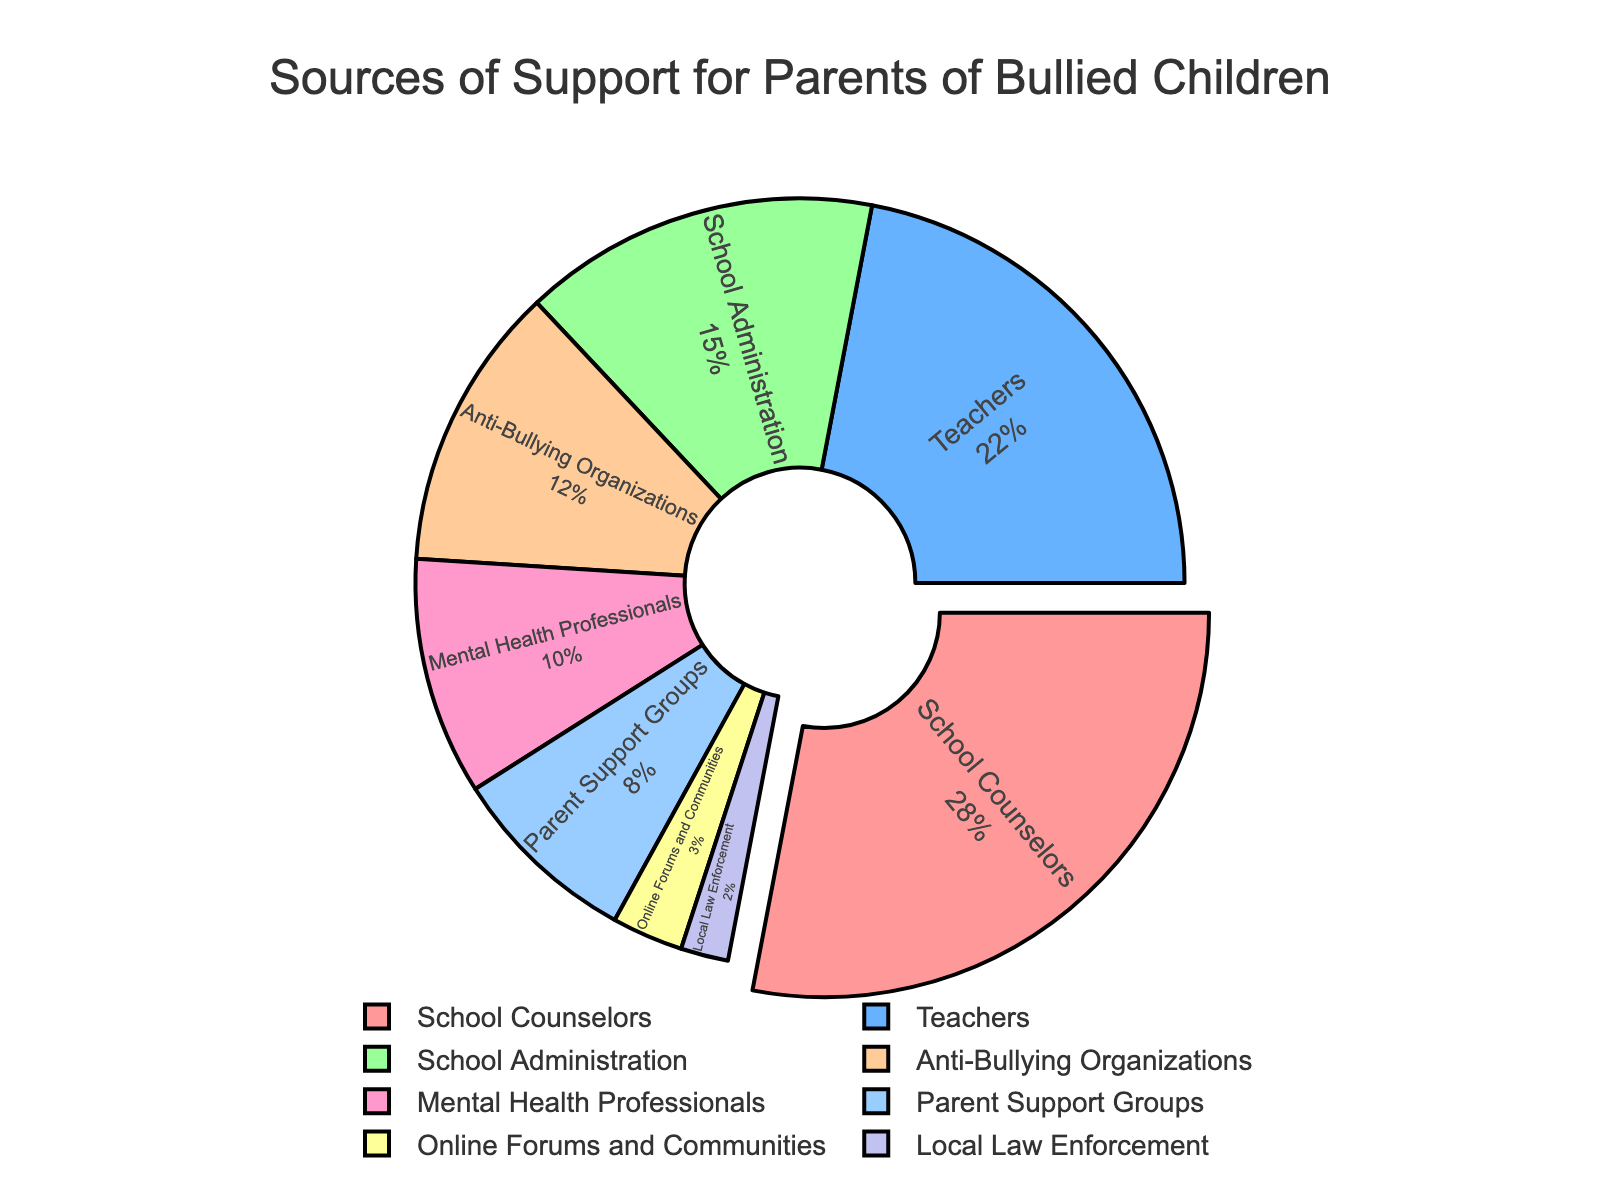What's the most common source of support sought by parents of bullied children? The largest segment in the pie chart indicates the most common source. The "School Counselors" segment is the largest.
Answer: School Counselors Which source of support is least sought by parents? The smallest segment represents the least sought source. The "Local Law Enforcement" segment is the smallest.
Answer: Local Law Enforcement What percentage of support is sought from resources other than "School Counselors"? Sum the percentages of all other segments: 100% - 28%
Answer: 72% How much more frequently do parents seek support from Teachers compared to Anti-Bullying Organizations? Subtract the percentage of Anti-Bullying Organizations from Teachers: 22% - 12%
Answer: 10% What is the combined percentage of parents seeking support from Mental Health Professionals and Parent Support Groups? Sum the percentages for both resources: 10% + 8%
Answer: 18% What's the difference in percentage between the support sought from School Administration and Anti-Bullying Organizations? Subtract the percentage of Anti-Bullying Organizations from School Administration: 15% - 12%
Answer: 3% Which two sources of support have similar percentages? Compare percentages visually. School Administration (15%) and Anti-Bullying Organizations (12%) are the closest, differing by only 3%.
Answer: School Administration and Anti-Bullying Organizations By what factor is the percentage seeking support from Online Forums and Communities smaller than from Teachers? Divide the percentage for Teachers by that for Online Forums and Communities: 22% / 3% = 7.33
Answer: 7.33 What are the colors representing "Mental Health Professionals" and "Parent Support Groups" in the chart? Identify and describe the colors from the legend. "Mental Health Professionals" is represented by a light pink color, and "Parent Support Groups" is represented by a light blue color.
Answer: Light pink and light blue How many more parents seek support from School Counselors than from School Administration? Subtract the percentage for School Administration from School Counselors: 28% - 15%
Answer: 13% 